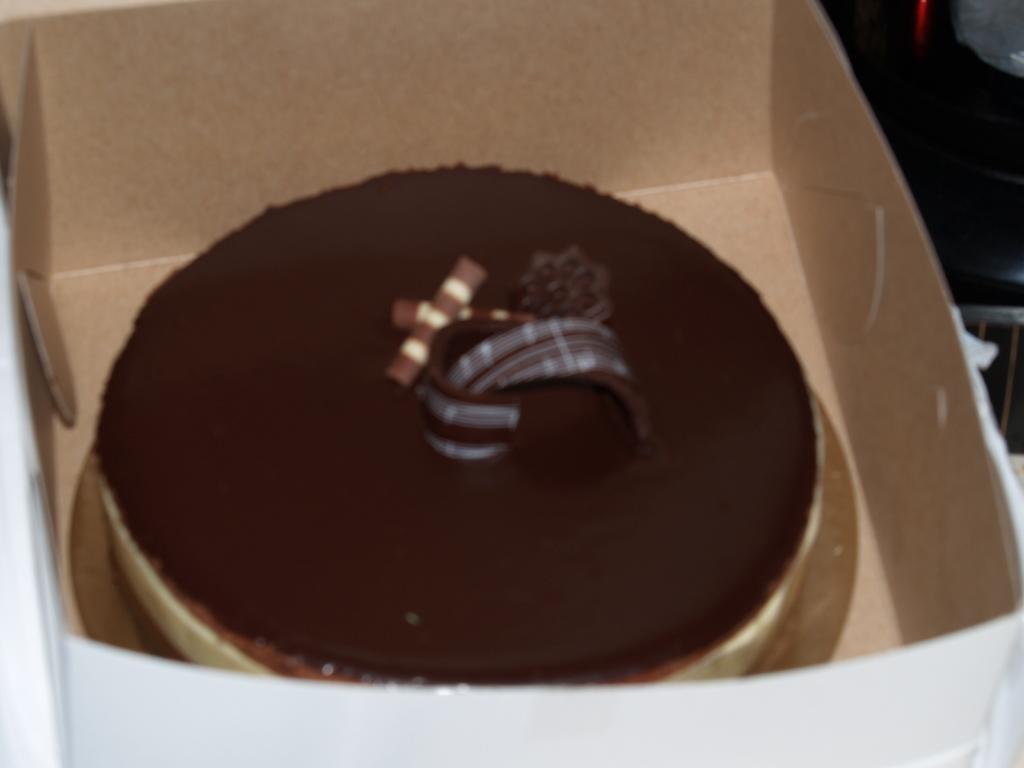How would you summarize this image in a sentence or two? In the foreground of this image, there is a cake in cardboard box and on the top right, there are objects which are not visible. 